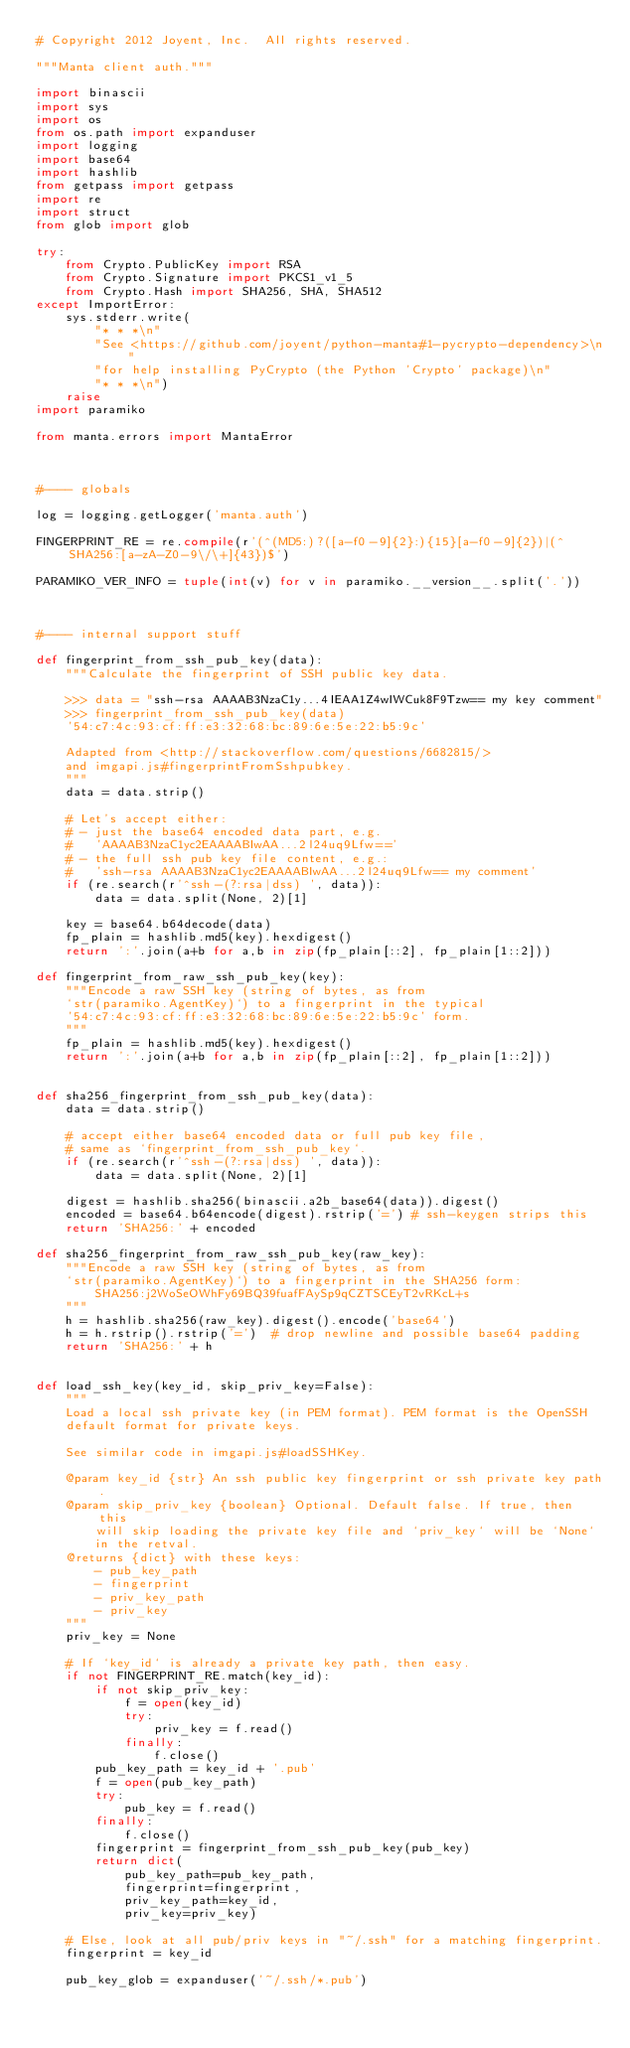<code> <loc_0><loc_0><loc_500><loc_500><_Python_># Copyright 2012 Joyent, Inc.  All rights reserved.

"""Manta client auth."""

import binascii
import sys
import os
from os.path import expanduser
import logging
import base64
import hashlib
from getpass import getpass
import re
import struct
from glob import glob

try:
    from Crypto.PublicKey import RSA
    from Crypto.Signature import PKCS1_v1_5
    from Crypto.Hash import SHA256, SHA, SHA512
except ImportError:
    sys.stderr.write(
        "* * *\n"
        "See <https://github.com/joyent/python-manta#1-pycrypto-dependency>\n"
        "for help installing PyCrypto (the Python 'Crypto' package)\n"
        "* * *\n")
    raise
import paramiko

from manta.errors import MantaError



#---- globals

log = logging.getLogger('manta.auth')

FINGERPRINT_RE = re.compile(r'(^(MD5:)?([a-f0-9]{2}:){15}[a-f0-9]{2})|(^SHA256:[a-zA-Z0-9\/\+]{43})$')

PARAMIKO_VER_INFO = tuple(int(v) for v in paramiko.__version__.split('.'))



#---- internal support stuff

def fingerprint_from_ssh_pub_key(data):
    """Calculate the fingerprint of SSH public key data.

    >>> data = "ssh-rsa AAAAB3NzaC1y...4IEAA1Z4wIWCuk8F9Tzw== my key comment"
    >>> fingerprint_from_ssh_pub_key(data)
    '54:c7:4c:93:cf:ff:e3:32:68:bc:89:6e:5e:22:b5:9c'

    Adapted from <http://stackoverflow.com/questions/6682815/>
    and imgapi.js#fingerprintFromSshpubkey.
    """
    data = data.strip()

    # Let's accept either:
    # - just the base64 encoded data part, e.g.
    #   'AAAAB3NzaC1yc2EAAAABIwAA...2l24uq9Lfw=='
    # - the full ssh pub key file content, e.g.:
    #   'ssh-rsa AAAAB3NzaC1yc2EAAAABIwAA...2l24uq9Lfw== my comment'
    if (re.search(r'^ssh-(?:rsa|dss) ', data)):
        data = data.split(None, 2)[1]

    key = base64.b64decode(data)
    fp_plain = hashlib.md5(key).hexdigest()
    return ':'.join(a+b for a,b in zip(fp_plain[::2], fp_plain[1::2]))

def fingerprint_from_raw_ssh_pub_key(key):
    """Encode a raw SSH key (string of bytes, as from
    `str(paramiko.AgentKey)`) to a fingerprint in the typical
    '54:c7:4c:93:cf:ff:e3:32:68:bc:89:6e:5e:22:b5:9c' form.
    """
    fp_plain = hashlib.md5(key).hexdigest()
    return ':'.join(a+b for a,b in zip(fp_plain[::2], fp_plain[1::2]))


def sha256_fingerprint_from_ssh_pub_key(data):
    data = data.strip()

    # accept either base64 encoded data or full pub key file,
    # same as `fingerprint_from_ssh_pub_key`.
    if (re.search(r'^ssh-(?:rsa|dss) ', data)):
        data = data.split(None, 2)[1]

    digest = hashlib.sha256(binascii.a2b_base64(data)).digest()
    encoded = base64.b64encode(digest).rstrip('=') # ssh-keygen strips this
    return 'SHA256:' + encoded

def sha256_fingerprint_from_raw_ssh_pub_key(raw_key):
    """Encode a raw SSH key (string of bytes, as from
    `str(paramiko.AgentKey)`) to a fingerprint in the SHA256 form:
        SHA256:j2WoSeOWhFy69BQ39fuafFAySp9qCZTSCEyT2vRKcL+s
    """
    h = hashlib.sha256(raw_key).digest().encode('base64')
    h = h.rstrip().rstrip('=')  # drop newline and possible base64 padding
    return 'SHA256:' + h


def load_ssh_key(key_id, skip_priv_key=False):
    """
    Load a local ssh private key (in PEM format). PEM format is the OpenSSH
    default format for private keys.

    See similar code in imgapi.js#loadSSHKey.

    @param key_id {str} An ssh public key fingerprint or ssh private key path.
    @param skip_priv_key {boolean} Optional. Default false. If true, then this
        will skip loading the private key file and `priv_key` will be `None`
        in the retval.
    @returns {dict} with these keys:
        - pub_key_path
        - fingerprint
        - priv_key_path
        - priv_key
    """
    priv_key = None

    # If `key_id` is already a private key path, then easy.
    if not FINGERPRINT_RE.match(key_id):
        if not skip_priv_key:
            f = open(key_id)
            try:
                priv_key = f.read()
            finally:
                f.close()
        pub_key_path = key_id + '.pub'
        f = open(pub_key_path)
        try:
            pub_key = f.read()
        finally:
            f.close()
        fingerprint = fingerprint_from_ssh_pub_key(pub_key)
        return dict(
            pub_key_path=pub_key_path,
            fingerprint=fingerprint,
            priv_key_path=key_id,
            priv_key=priv_key)

    # Else, look at all pub/priv keys in "~/.ssh" for a matching fingerprint.
    fingerprint = key_id

    pub_key_glob = expanduser('~/.ssh/*.pub')</code> 